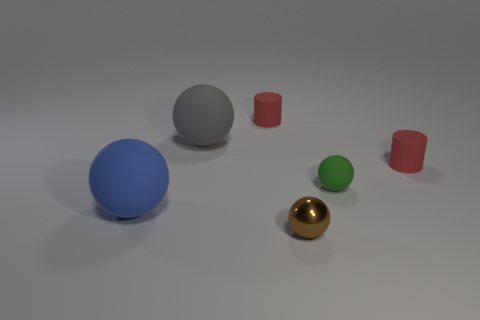Subtract all blue spheres. How many spheres are left? 3 Add 3 large yellow matte cubes. How many objects exist? 9 Subtract all green balls. How many balls are left? 3 Subtract all balls. How many objects are left? 2 Subtract 2 balls. How many balls are left? 2 Add 5 small red rubber cylinders. How many small red rubber cylinders exist? 7 Subtract 0 gray cylinders. How many objects are left? 6 Subtract all red spheres. Subtract all yellow cylinders. How many spheres are left? 4 Subtract all red cylinders. Subtract all brown metal objects. How many objects are left? 3 Add 1 large rubber objects. How many large rubber objects are left? 3 